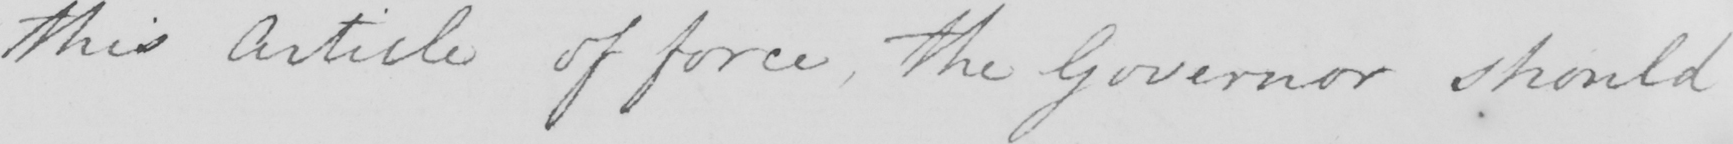Please transcribe the handwritten text in this image. this Article of force , the Governor should 